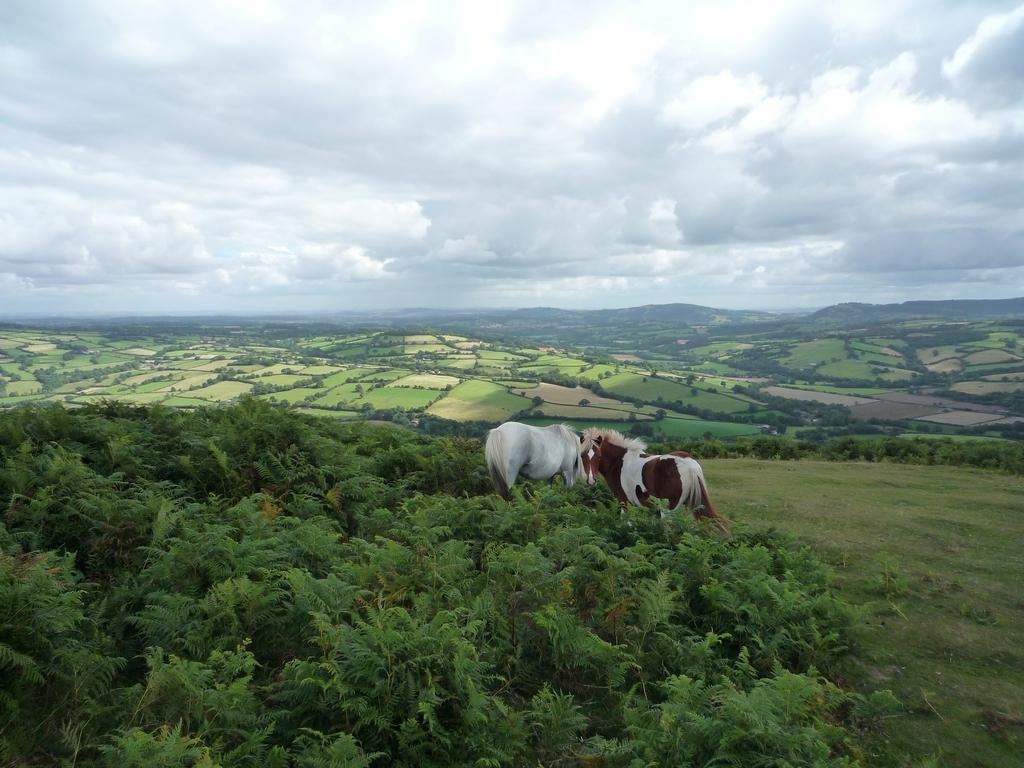What type of vegetation is in the front of the image? There are plants in the front of the image. What can be seen in the center of the image? There are animals in the center of the image. What is visible in the background of the image? There are trees in the background of the image. What type of ground cover is present in the image? There is grass on the ground in the image. What is the condition of the sky in the image? The sky is cloudy in the image. Is there any waste visible in the image? There is no mention of waste in the provided facts, so we cannot determine if it is present in the image. Can you hear thunder in the image? The provided facts do not mention any sounds, so we cannot determine if thunder is audible in the image. 